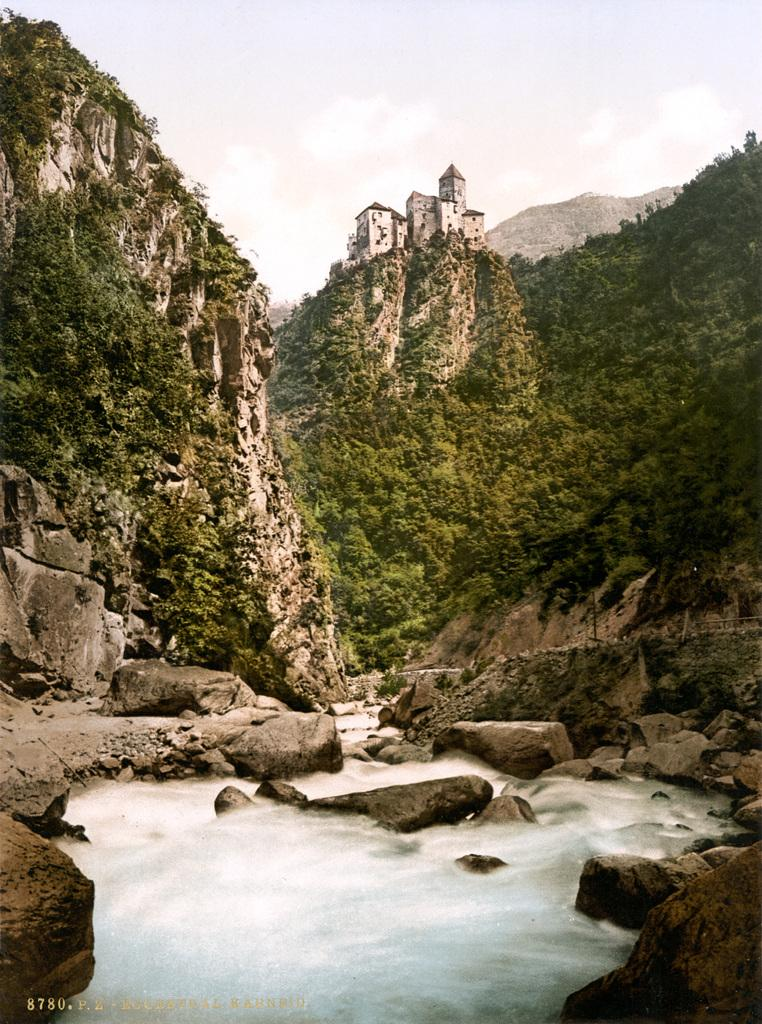What is the primary natural element in the image? There is water in the image. What type of vegetation can be seen in the image? There are trees in the image. What geographical features are present in the image? There are hills in the image. What type of structure is visible in the image? There is a building in the image. What part of the natural environment is visible in the image? The sky is visible in the image. What song is being sung by the boys in the image? There are no boys or any indication of singing in the image. 